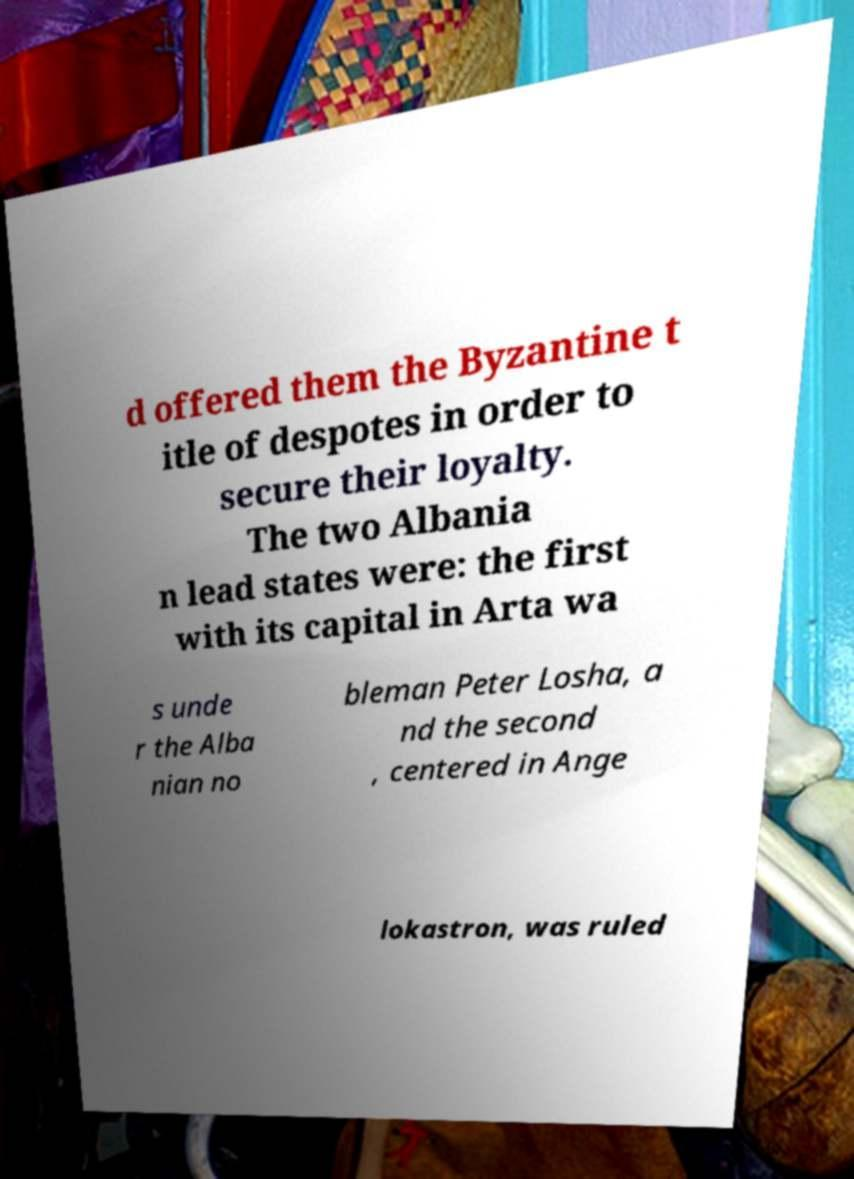Could you assist in decoding the text presented in this image and type it out clearly? d offered them the Byzantine t itle of despotes in order to secure their loyalty. The two Albania n lead states were: the first with its capital in Arta wa s unde r the Alba nian no bleman Peter Losha, a nd the second , centered in Ange lokastron, was ruled 